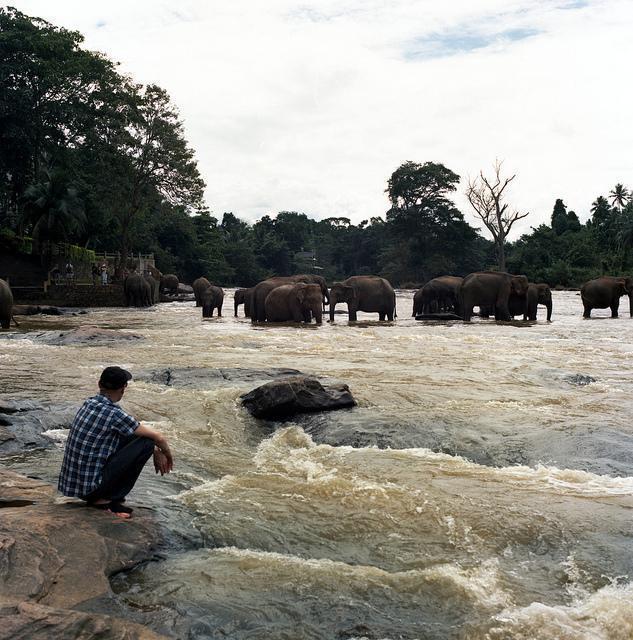What poses the greatest immediate danger to the man?
Pick the right solution, then justify: 'Answer: answer
Rationale: rationale.'
Options: Rockslide, waves, tiger, spiders. Answer: waves.
Rationale: There's only water near the man, which looks quite violent due to the current. 